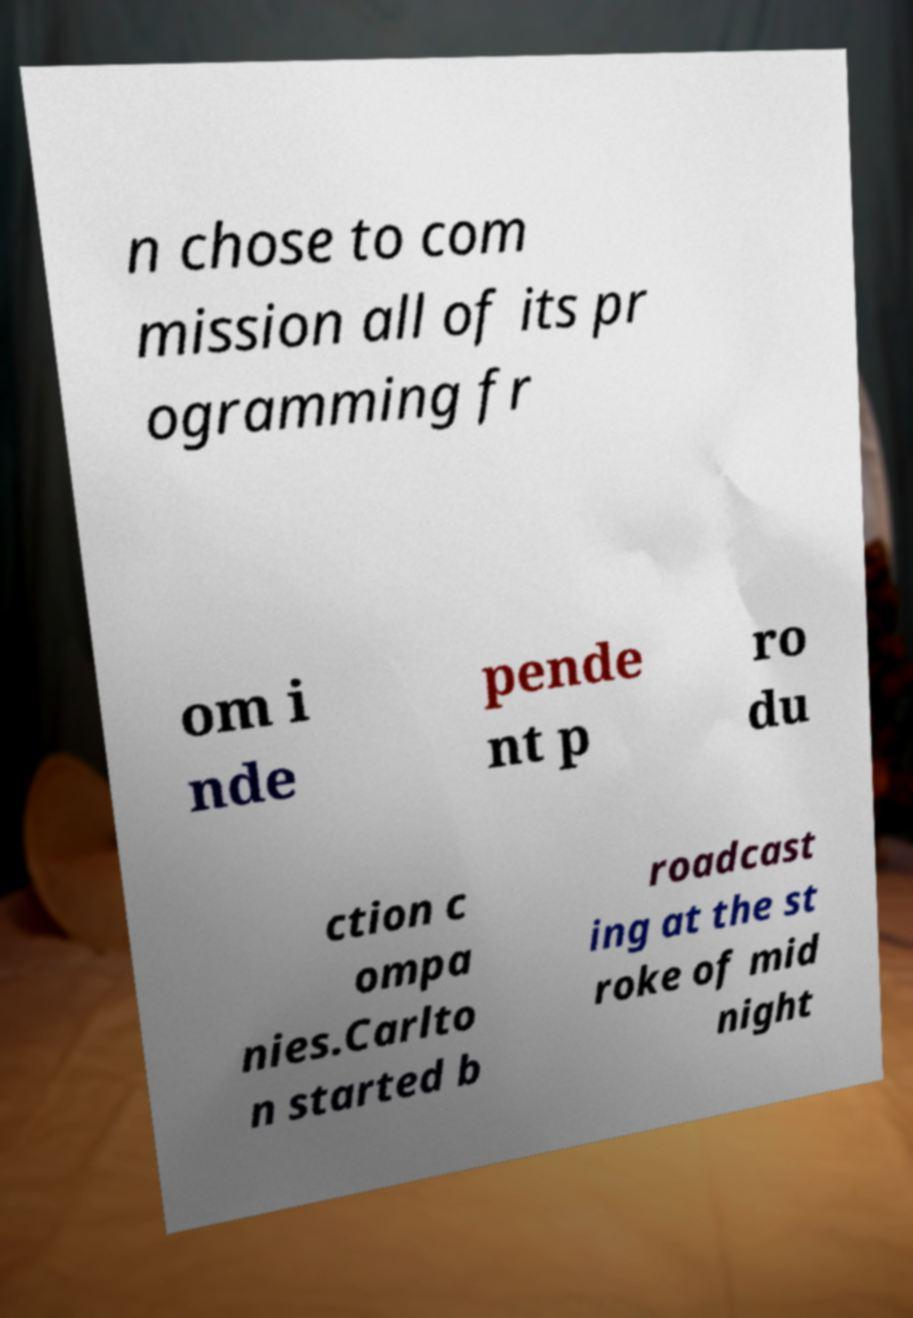Could you assist in decoding the text presented in this image and type it out clearly? n chose to com mission all of its pr ogramming fr om i nde pende nt p ro du ction c ompa nies.Carlto n started b roadcast ing at the st roke of mid night 